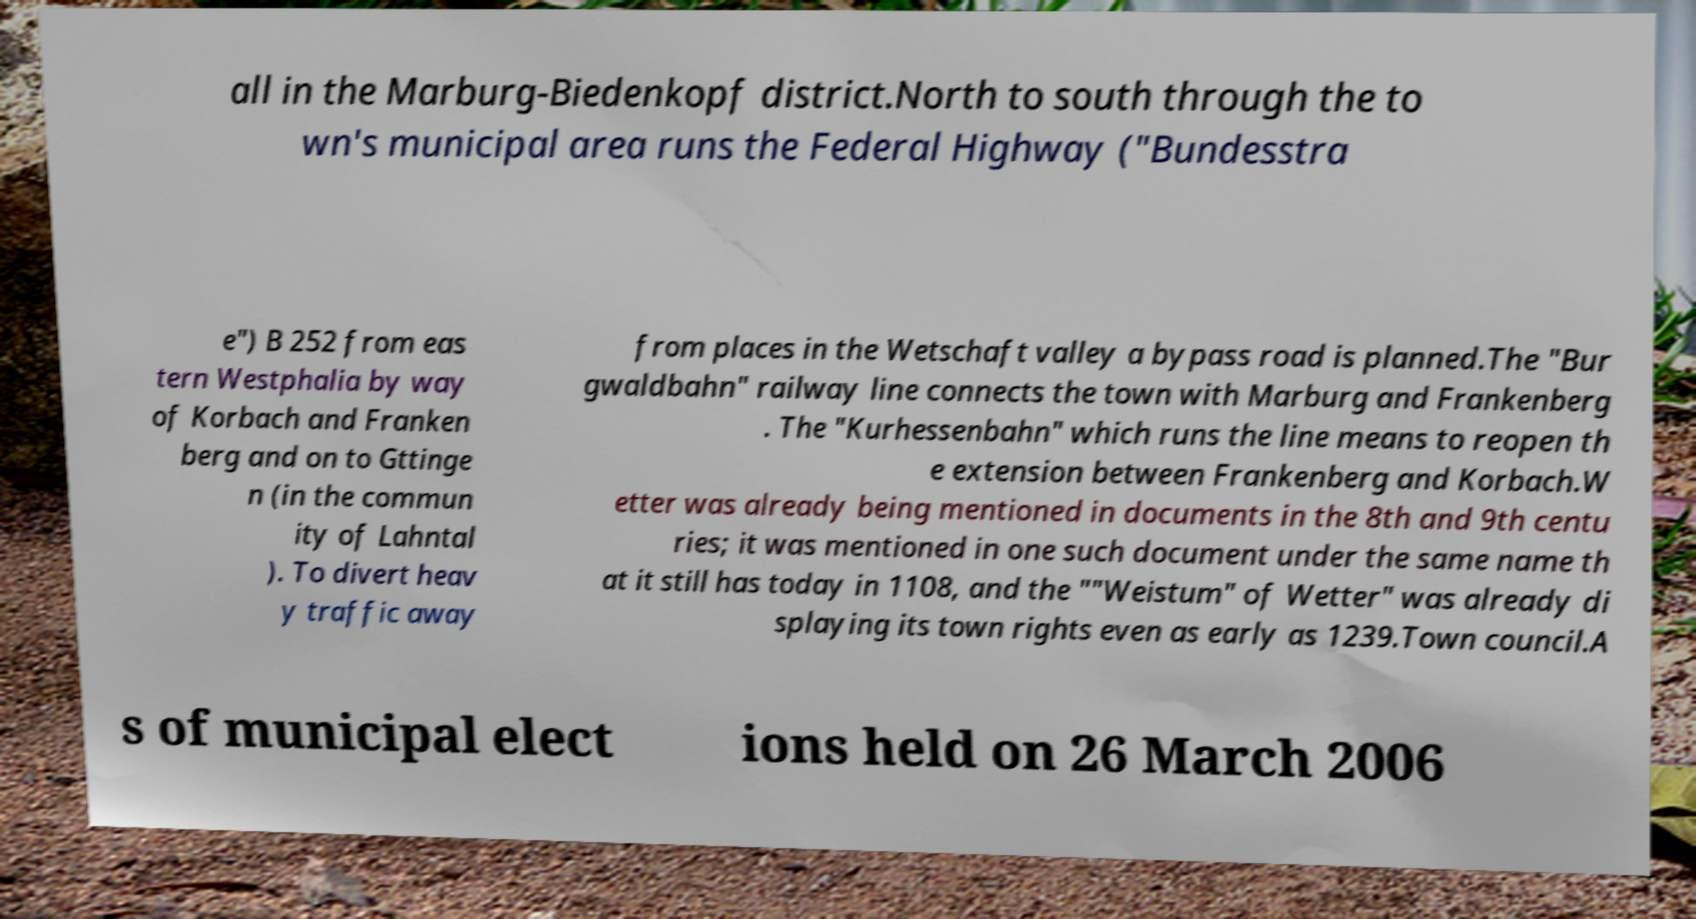Could you extract and type out the text from this image? all in the Marburg-Biedenkopf district.North to south through the to wn's municipal area runs the Federal Highway ("Bundesstra e") B 252 from eas tern Westphalia by way of Korbach and Franken berg and on to Gttinge n (in the commun ity of Lahntal ). To divert heav y traffic away from places in the Wetschaft valley a bypass road is planned.The "Bur gwaldbahn" railway line connects the town with Marburg and Frankenberg . The "Kurhessenbahn" which runs the line means to reopen th e extension between Frankenberg and Korbach.W etter was already being mentioned in documents in the 8th and 9th centu ries; it was mentioned in one such document under the same name th at it still has today in 1108, and the ""Weistum" of Wetter" was already di splaying its town rights even as early as 1239.Town council.A s of municipal elect ions held on 26 March 2006 